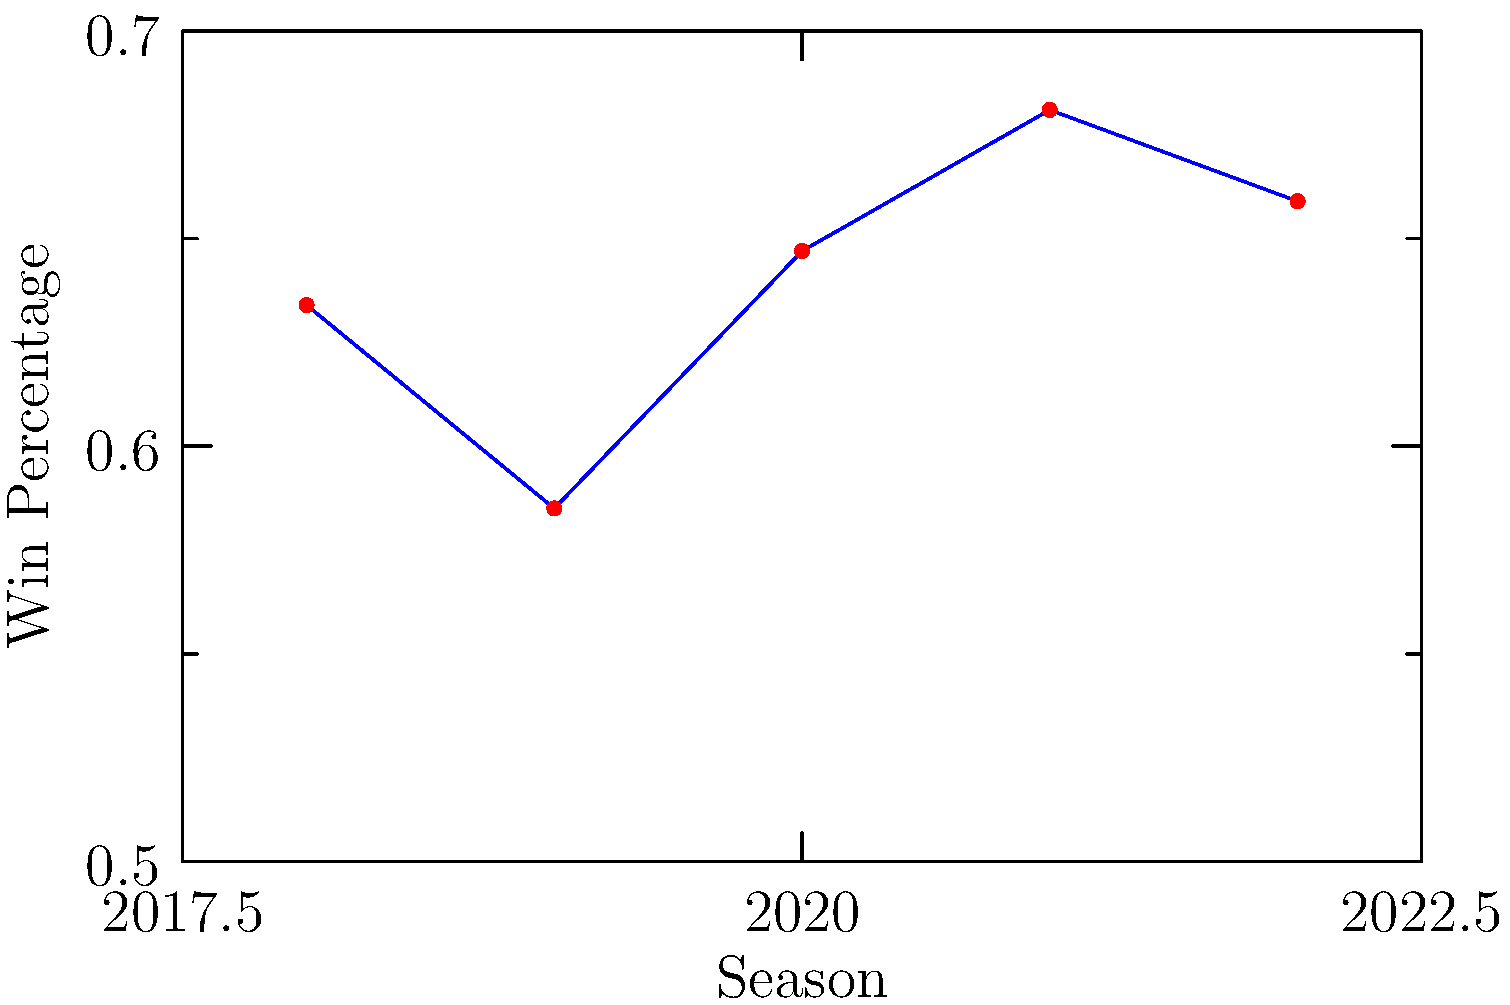As a dedicated 76ers fan, you've been tracking the team's performance over the past five seasons. The line graph shows the win percentage for each season from 2018 to 2022. In which season did the 76ers achieve their highest win percentage, and how might this information be relevant in your HR role when discussing team performance? To answer this question, we need to analyze the line graph and identify the highest point, which represents the best win percentage:

1. Examine each data point on the graph:
   2018: Approximately 0.634
   2019: Approximately 0.585
   2020: Approximately 0.647
   2021: Approximately 0.681
   2022: Approximately 0.659

2. The highest point on the graph corresponds to the 2021 season, with a win percentage of about 0.681.

3. This information is relevant in an HR role when discussing team performance because:
   a) It demonstrates the importance of tracking performance metrics over time.
   b) It shows how performance can fluctuate from year to year, emphasizing the need for consistent effort and improvement.
   c) It provides a benchmark for setting goals and evaluating success in future seasons.
   d) It can be used as an example of how to visualize and present performance data in a clear, understandable format.

4. In HR discussions, you could use this as an analogy for employee or department performance, highlighting the importance of:
   a) Setting clear performance targets
   b) Regularly measuring and tracking progress
   c) Identifying trends and areas for improvement
   d) Celebrating successes (like the peak performance in 2021)

5. This graph could also serve as a talking point for discussing resilience and continuous improvement, as the team's performance has remained relatively strong despite some fluctuations.
Answer: 2021 season (0.681 win percentage) 